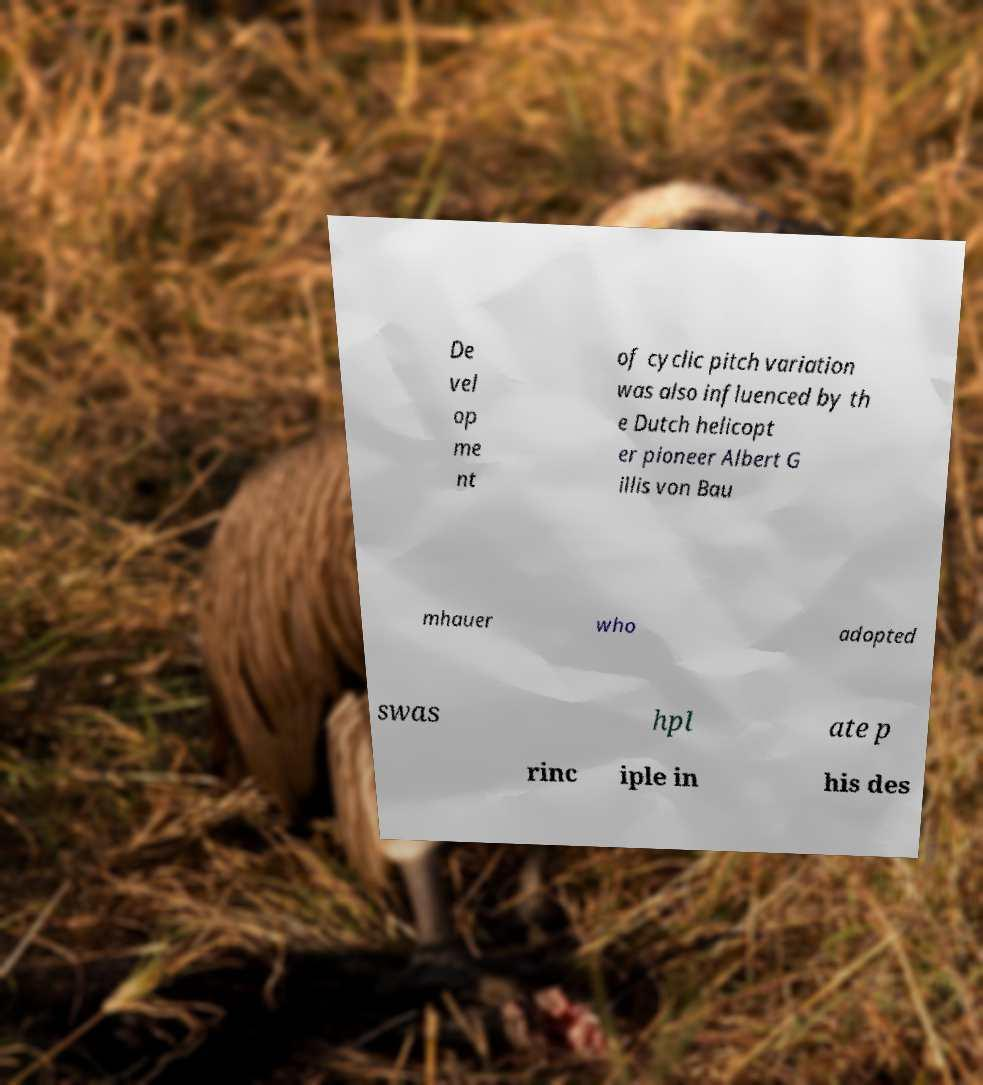Please identify and transcribe the text found in this image. De vel op me nt of cyclic pitch variation was also influenced by th e Dutch helicopt er pioneer Albert G illis von Bau mhauer who adopted swas hpl ate p rinc iple in his des 